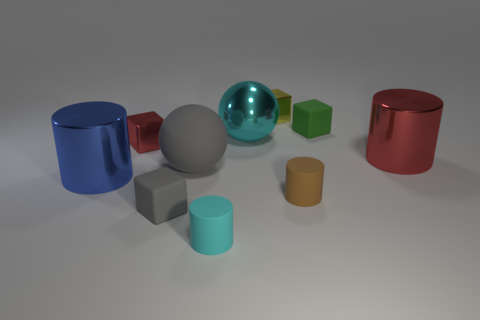Subtract all cyan rubber cylinders. How many cylinders are left? 3 Subtract all balls. How many objects are left? 8 Subtract all yellow spheres. Subtract all gray rubber cubes. How many objects are left? 9 Add 4 small gray rubber things. How many small gray rubber things are left? 5 Add 5 cubes. How many cubes exist? 9 Subtract all red cylinders. How many cylinders are left? 3 Subtract 1 gray cubes. How many objects are left? 9 Subtract 4 blocks. How many blocks are left? 0 Subtract all purple blocks. Subtract all red spheres. How many blocks are left? 4 Subtract all red blocks. How many gray spheres are left? 1 